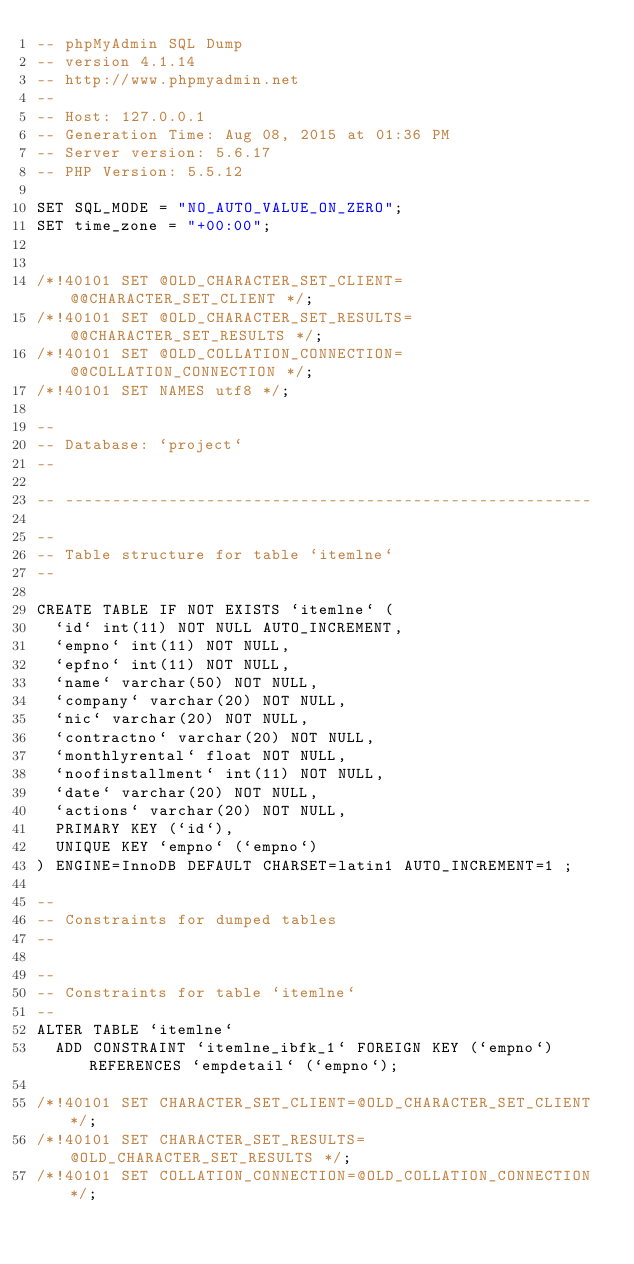Convert code to text. <code><loc_0><loc_0><loc_500><loc_500><_SQL_>-- phpMyAdmin SQL Dump
-- version 4.1.14
-- http://www.phpmyadmin.net
--
-- Host: 127.0.0.1
-- Generation Time: Aug 08, 2015 at 01:36 PM
-- Server version: 5.6.17
-- PHP Version: 5.5.12

SET SQL_MODE = "NO_AUTO_VALUE_ON_ZERO";
SET time_zone = "+00:00";


/*!40101 SET @OLD_CHARACTER_SET_CLIENT=@@CHARACTER_SET_CLIENT */;
/*!40101 SET @OLD_CHARACTER_SET_RESULTS=@@CHARACTER_SET_RESULTS */;
/*!40101 SET @OLD_COLLATION_CONNECTION=@@COLLATION_CONNECTION */;
/*!40101 SET NAMES utf8 */;

--
-- Database: `project`
--

-- --------------------------------------------------------

--
-- Table structure for table `itemlne`
--

CREATE TABLE IF NOT EXISTS `itemlne` (
  `id` int(11) NOT NULL AUTO_INCREMENT,
  `empno` int(11) NOT NULL,
  `epfno` int(11) NOT NULL,
  `name` varchar(50) NOT NULL,
  `company` varchar(20) NOT NULL,
  `nic` varchar(20) NOT NULL,
  `contractno` varchar(20) NOT NULL,
  `monthlyrental` float NOT NULL,
  `noofinstallment` int(11) NOT NULL,
  `date` varchar(20) NOT NULL,
  `actions` varchar(20) NOT NULL,
  PRIMARY KEY (`id`),
  UNIQUE KEY `empno` (`empno`)
) ENGINE=InnoDB DEFAULT CHARSET=latin1 AUTO_INCREMENT=1 ;

--
-- Constraints for dumped tables
--

--
-- Constraints for table `itemlne`
--
ALTER TABLE `itemlne`
  ADD CONSTRAINT `itemlne_ibfk_1` FOREIGN KEY (`empno`) REFERENCES `empdetail` (`empno`);

/*!40101 SET CHARACTER_SET_CLIENT=@OLD_CHARACTER_SET_CLIENT */;
/*!40101 SET CHARACTER_SET_RESULTS=@OLD_CHARACTER_SET_RESULTS */;
/*!40101 SET COLLATION_CONNECTION=@OLD_COLLATION_CONNECTION */;
</code> 